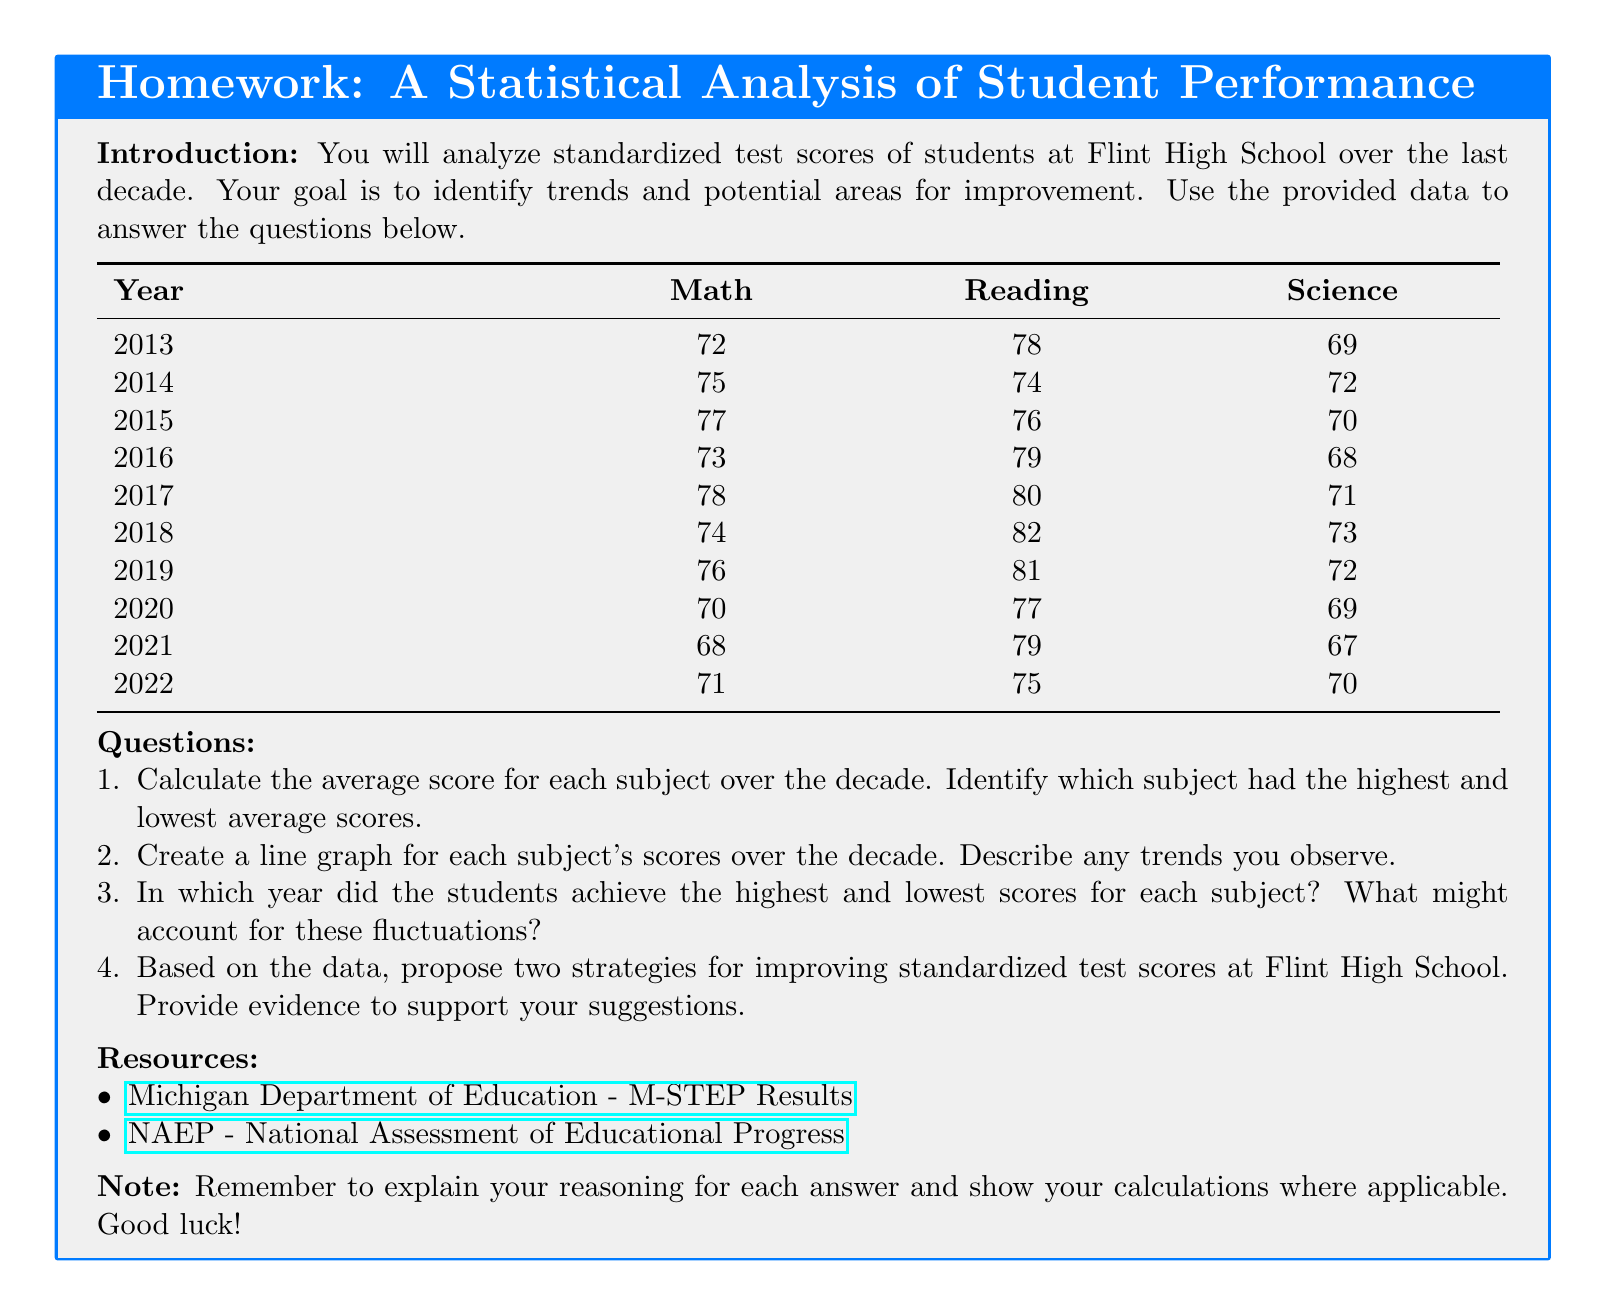What was the average Math score over the decade? The average Math score is calculated by summing all the Math scores from the years 2013 to 2022 and dividing by the number of years.
Answer: 73.5 What year had the lowest Reading score? The lowest Reading score is identified by looking for the minimum value in the Reading column from the table.
Answer: 2022 Which subject had the highest average score? The subject with the highest average score is determined by comparing the average scores of Math, Reading, and Science.
Answer: Reading In what year did students achieve the highest Science score? The year with the highest Science score is found by locating the maximum value in the Science column from the table.
Answer: 2014 What trend is observed in Math scores from 2013 to 2022? The trend in Math scores is assessed by analyzing how the scores change over the years, noting any increases or decreases.
Answer: Fluctuating List two proposed strategies for improving test scores. The strategies can be based on the analysis of trends and weaknesses identified in student performance over the decade.
Answer: Targeted tutoring, Curriculum enhancement What was the Science score in 2020? The specific Science score for the year 2020 is retrieved directly from the corresponding year's data in the table.
Answer: 69 Which year had the highest Reading score? The year with the highest Reading score is determined by locating the maximum value in the Reading column from the provided data.
Answer: 2018 What are the two resources provided for further information? The resources for further research are mentioned at the end of the document.
Answer: Michigan Department of Education, NAEP 